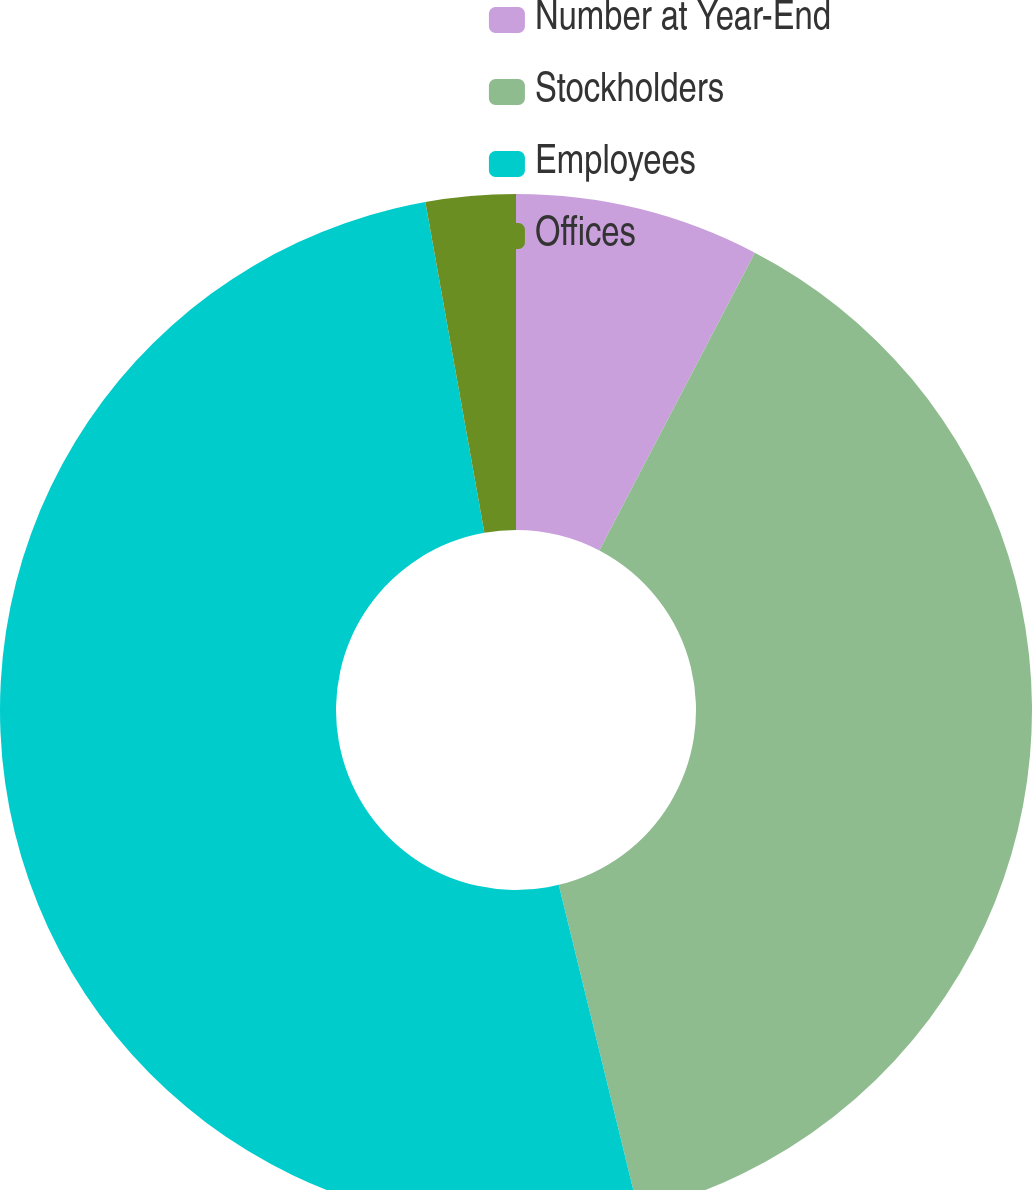Convert chart to OTSL. <chart><loc_0><loc_0><loc_500><loc_500><pie_chart><fcel>Number at Year-End<fcel>Stockholders<fcel>Employees<fcel>Offices<nl><fcel>7.66%<fcel>38.52%<fcel>51.0%<fcel>2.81%<nl></chart> 